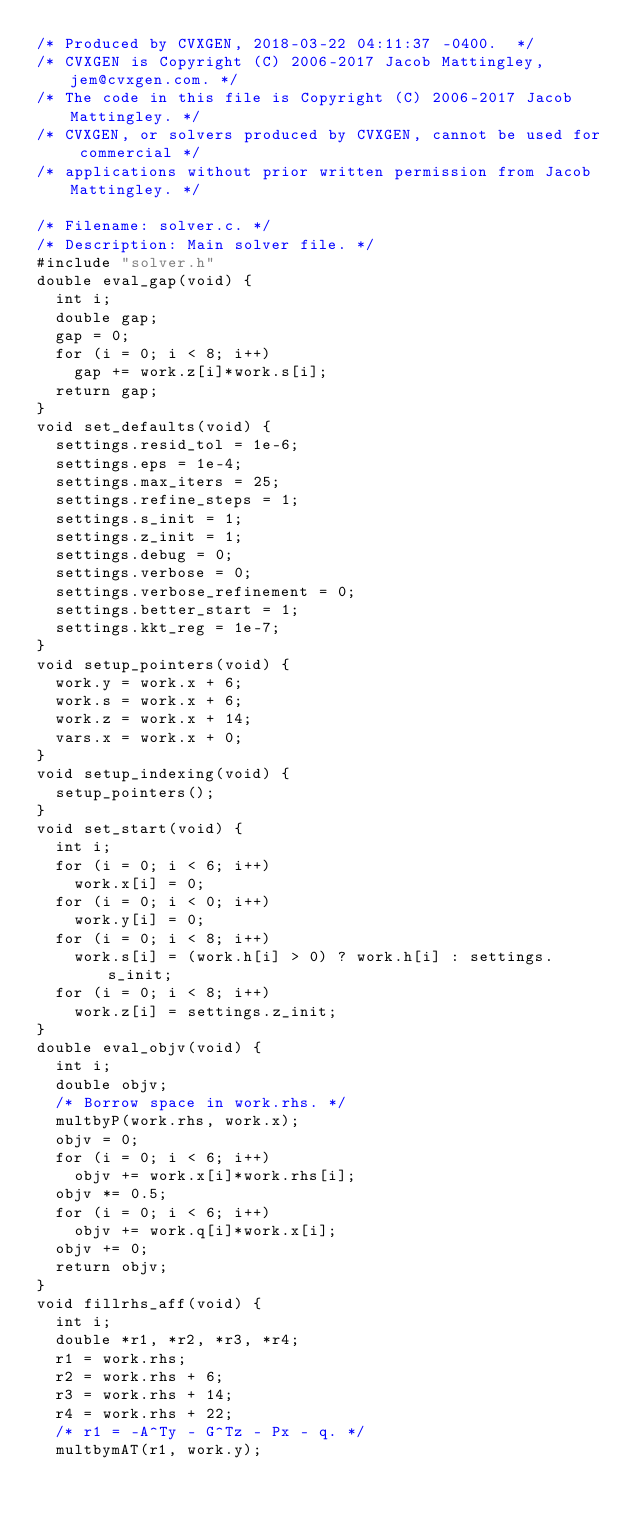<code> <loc_0><loc_0><loc_500><loc_500><_C++_>/* Produced by CVXGEN, 2018-03-22 04:11:37 -0400.  */
/* CVXGEN is Copyright (C) 2006-2017 Jacob Mattingley, jem@cvxgen.com. */
/* The code in this file is Copyright (C) 2006-2017 Jacob Mattingley. */
/* CVXGEN, or solvers produced by CVXGEN, cannot be used for commercial */
/* applications without prior written permission from Jacob Mattingley. */

/* Filename: solver.c. */
/* Description: Main solver file. */
#include "solver.h"
double eval_gap(void) {
  int i;
  double gap;
  gap = 0;
  for (i = 0; i < 8; i++)
    gap += work.z[i]*work.s[i];
  return gap;
}
void set_defaults(void) {
  settings.resid_tol = 1e-6;
  settings.eps = 1e-4;
  settings.max_iters = 25;
  settings.refine_steps = 1;
  settings.s_init = 1;
  settings.z_init = 1;
  settings.debug = 0;
  settings.verbose = 0;
  settings.verbose_refinement = 0;
  settings.better_start = 1;
  settings.kkt_reg = 1e-7;
}
void setup_pointers(void) {
  work.y = work.x + 6;
  work.s = work.x + 6;
  work.z = work.x + 14;
  vars.x = work.x + 0;
}
void setup_indexing(void) {
  setup_pointers();
}
void set_start(void) {
  int i;
  for (i = 0; i < 6; i++)
    work.x[i] = 0;
  for (i = 0; i < 0; i++)
    work.y[i] = 0;
  for (i = 0; i < 8; i++)
    work.s[i] = (work.h[i] > 0) ? work.h[i] : settings.s_init;
  for (i = 0; i < 8; i++)
    work.z[i] = settings.z_init;
}
double eval_objv(void) {
  int i;
  double objv;
  /* Borrow space in work.rhs. */
  multbyP(work.rhs, work.x);
  objv = 0;
  for (i = 0; i < 6; i++)
    objv += work.x[i]*work.rhs[i];
  objv *= 0.5;
  for (i = 0; i < 6; i++)
    objv += work.q[i]*work.x[i];
  objv += 0;
  return objv;
}
void fillrhs_aff(void) {
  int i;
  double *r1, *r2, *r3, *r4;
  r1 = work.rhs;
  r2 = work.rhs + 6;
  r3 = work.rhs + 14;
  r4 = work.rhs + 22;
  /* r1 = -A^Ty - G^Tz - Px - q. */
  multbymAT(r1, work.y);</code> 